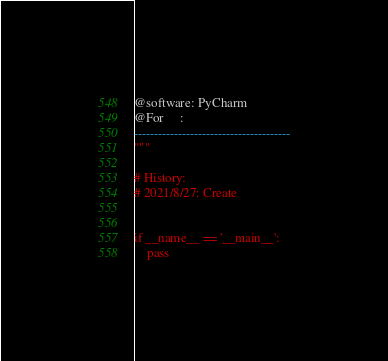<code> <loc_0><loc_0><loc_500><loc_500><_Python_>@software: PyCharm
@For     : 
---------------------------------------
"""

# History:
# 2021/8/27: Create


if __name__ == '__main__':
    pass
</code> 